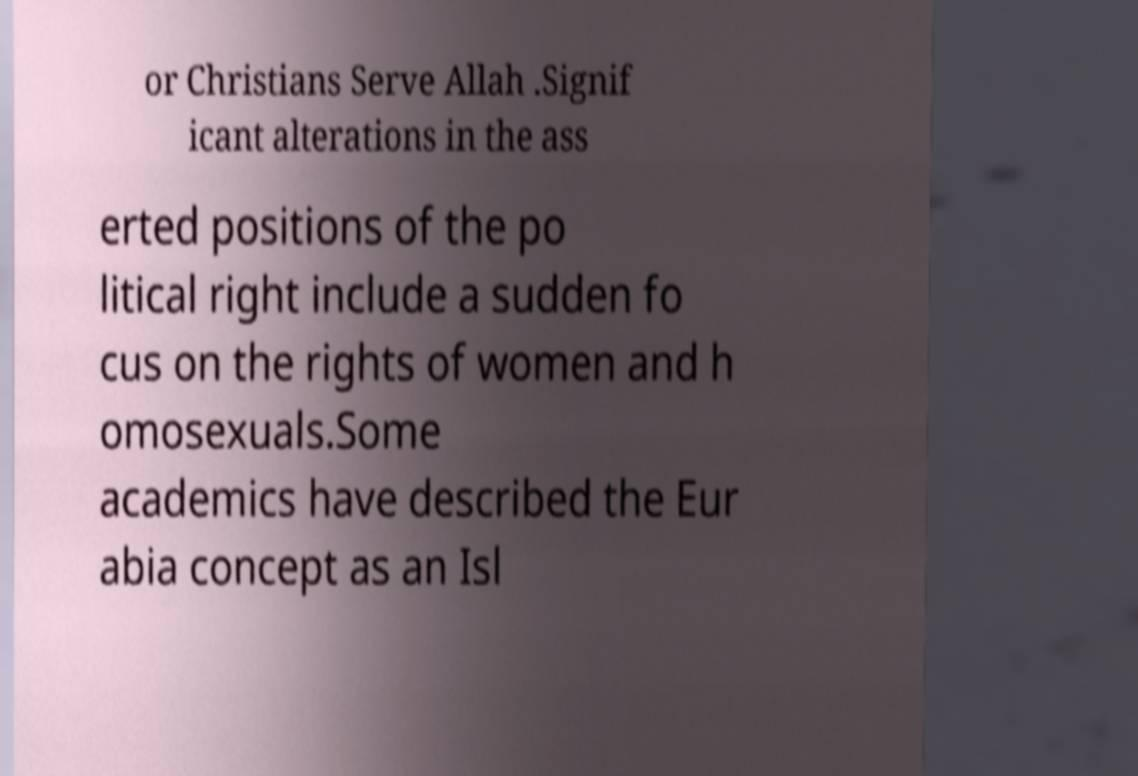Can you accurately transcribe the text from the provided image for me? or Christians Serve Allah .Signif icant alterations in the ass erted positions of the po litical right include a sudden fo cus on the rights of women and h omosexuals.Some academics have described the Eur abia concept as an Isl 